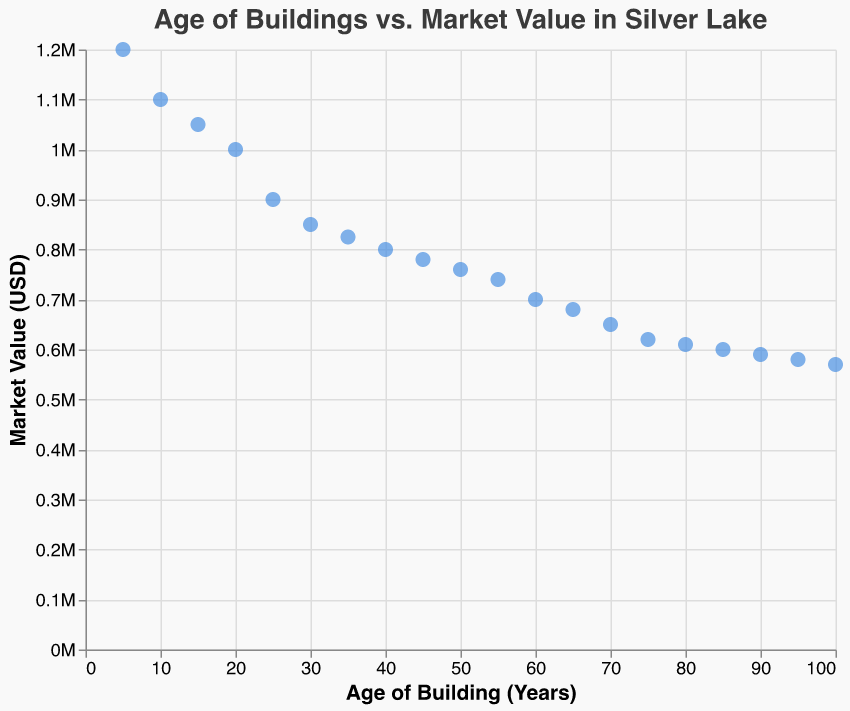What's the title of the scatter plot? The title of the scatter plot is displayed at the top of the figure. It reads "Age of Buildings vs. Market Value in Silver Lake".
Answer: Age of Buildings vs. Market Value in Silver Lake How many data points are present in the plot? The scatter plot has data points for buildings with ages ranging from 5 to 100 years. Each age has one corresponding market value, resulting in one point per building age. There are 20 building ages listed, therefore there are 20 data points.
Answer: 20 What is the market value of a building that is 30 years old? To determine the market value of a building that is 30 years old, locate the point corresponding to the age of 30 on the x-axis. The y-axis value of this point is the market value, which, according to the provided data, is 850,000 USD.
Answer: 850,000 USD What's the difference in market value between buildings aged 5 and 100 years? To find the difference in market value, locate the market values for buildings aged 5 and 100 years on the y-axis. The values are 1,200,000 USD and 570,000 USD respectively. Subtract the latter from the former: 1,200,000 - 570,000 = 630,000 USD.
Answer: 630,000 USD Which building age has the lowest market value? By examining the y-axis values for all data points, the building with the age of 100 years has the lowest market value, which is 570,000 USD.
Answer: 100 years How does the market value change as the age of the building increases? Observing the trend in the scatter plot, the market value decreases as the age of the building increases. Starting from 1,200,000 USD at 5 years old, it consistently goes down to 570,000 USD at 100 years old.
Answer: Decreases Which age group has a market value of approximately 800,000 USD? By locating the y-axis value of 800,000 USD and finding the corresponding x-axis value, buildings around 40 years old have a market value of approximately 800,000 USD.
Answer: 40 years Is there a clear pattern in the plot indicating the relationship between age and market value? Yes, there is a clear negative correlation visible between the age of buildings and their market value, indicating that as the age of the building increases, the market value tends to decrease.
Answer: Negative correlation What is the market value difference between buildings aged 60 and 80 years? To find the market value difference, locate the values for buildings aged 60 and 80 years, which are 700,000 USD and 610,000 USD, respectively. Subtract the value at 80 years from the value at 60 years: 700,000 - 610,000 = 90,000 USD.
Answer: 90,000 USD 